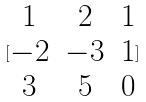Convert formula to latex. <formula><loc_0><loc_0><loc_500><loc_500>[ \begin{matrix} 1 & 2 & 1 \\ - 2 & - 3 & 1 \\ 3 & 5 & 0 \end{matrix} ]</formula> 